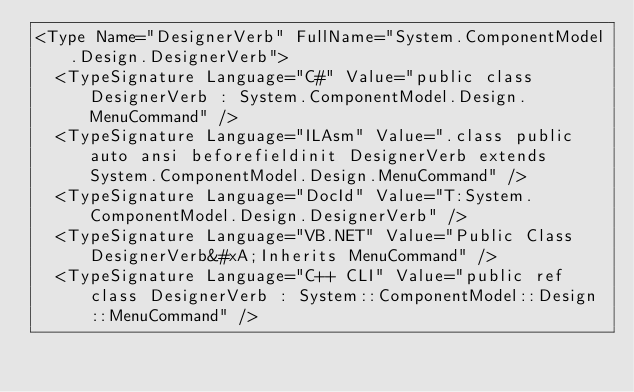<code> <loc_0><loc_0><loc_500><loc_500><_XML_><Type Name="DesignerVerb" FullName="System.ComponentModel.Design.DesignerVerb">
  <TypeSignature Language="C#" Value="public class DesignerVerb : System.ComponentModel.Design.MenuCommand" />
  <TypeSignature Language="ILAsm" Value=".class public auto ansi beforefieldinit DesignerVerb extends System.ComponentModel.Design.MenuCommand" />
  <TypeSignature Language="DocId" Value="T:System.ComponentModel.Design.DesignerVerb" />
  <TypeSignature Language="VB.NET" Value="Public Class DesignerVerb&#xA;Inherits MenuCommand" />
  <TypeSignature Language="C++ CLI" Value="public ref class DesignerVerb : System::ComponentModel::Design::MenuCommand" /></code> 